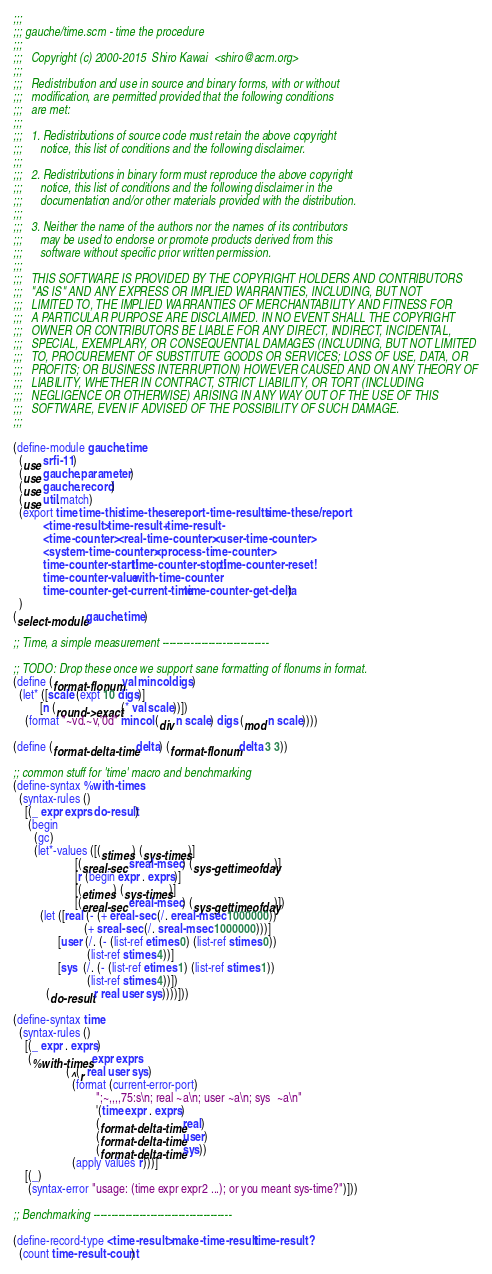Convert code to text. <code><loc_0><loc_0><loc_500><loc_500><_Scheme_>;;;
;;; gauche/time.scm - time the procedure
;;;
;;;   Copyright (c) 2000-2015  Shiro Kawai  <shiro@acm.org>
;;;
;;;   Redistribution and use in source and binary forms, with or without
;;;   modification, are permitted provided that the following conditions
;;;   are met:
;;;
;;;   1. Redistributions of source code must retain the above copyright
;;;      notice, this list of conditions and the following disclaimer.
;;;
;;;   2. Redistributions in binary form must reproduce the above copyright
;;;      notice, this list of conditions and the following disclaimer in the
;;;      documentation and/or other materials provided with the distribution.
;;;
;;;   3. Neither the name of the authors nor the names of its contributors
;;;      may be used to endorse or promote products derived from this
;;;      software without specific prior written permission.
;;;
;;;   THIS SOFTWARE IS PROVIDED BY THE COPYRIGHT HOLDERS AND CONTRIBUTORS
;;;   "AS IS" AND ANY EXPRESS OR IMPLIED WARRANTIES, INCLUDING, BUT NOT
;;;   LIMITED TO, THE IMPLIED WARRANTIES OF MERCHANTABILITY AND FITNESS FOR
;;;   A PARTICULAR PURPOSE ARE DISCLAIMED. IN NO EVENT SHALL THE COPYRIGHT
;;;   OWNER OR CONTRIBUTORS BE LIABLE FOR ANY DIRECT, INDIRECT, INCIDENTAL,
;;;   SPECIAL, EXEMPLARY, OR CONSEQUENTIAL DAMAGES (INCLUDING, BUT NOT LIMITED
;;;   TO, PROCUREMENT OF SUBSTITUTE GOODS OR SERVICES; LOSS OF USE, DATA, OR
;;;   PROFITS; OR BUSINESS INTERRUPTION) HOWEVER CAUSED AND ON ANY THEORY OF
;;;   LIABILITY, WHETHER IN CONTRACT, STRICT LIABILITY, OR TORT (INCLUDING
;;;   NEGLIGENCE OR OTHERWISE) ARISING IN ANY WAY OUT OF THE USE OF THIS
;;;   SOFTWARE, EVEN IF ADVISED OF THE POSSIBILITY OF SUCH DAMAGE.
;;;

(define-module gauche.time
  (use srfi-11)
  (use gauche.parameter)
  (use gauche.record)
  (use util.match)
  (export time time-this time-these report-time-results time-these/report
          <time-result> time-result+ time-result-
          <time-counter> <real-time-counter> <user-time-counter>
          <system-time-counter> <process-time-counter>
          time-counter-start! time-counter-stop! time-counter-reset!
          time-counter-value with-time-counter
          time-counter-get-current-time time-counter-get-delta)
  )
(select-module gauche.time)

;; Time, a simple measurement ------------------------------

;; TODO: Drop these once we support sane formatting of flonums in format.
(define (format-flonum val mincol digs)
  (let* ([scale (expt 10 digs)]
         [n (round->exact (* val scale))])
    (format "~vd.~v,'0d" mincol (div n scale) digs (mod n scale))))

(define (format-delta-time delta) (format-flonum delta 3 3))

;; common stuff for 'time' macro and benchmarking
(define-syntax %with-times
  (syntax-rules ()
    [(_ expr exprs do-result)
     (begin
       (gc)
       (let*-values ([(stimes) (sys-times)]
                     [(sreal-sec sreal-msec) (sys-gettimeofday)]
                     [r (begin expr . exprs)]
                     [(etimes) (sys-times)]
                     [(ereal-sec ereal-msec) (sys-gettimeofday)])
         (let ([real (- (+ ereal-sec (/. ereal-msec 1000000))
                        (+ sreal-sec (/. sreal-msec 1000000)))]
               [user (/. (- (list-ref etimes 0) (list-ref stimes 0))
                         (list-ref stimes 4))]
               [sys  (/. (- (list-ref etimes 1) (list-ref stimes 1))
                         (list-ref stimes 4))])
           (do-result r real user sys))))]))

(define-syntax time
  (syntax-rules ()
    [(_ expr . exprs)
     (%with-times expr exprs
                  (^(r real user sys)
                    (format (current-error-port)
                            ";~,,,,75:s\n; real ~a\n; user ~a\n; sys  ~a\n"
                            '(time expr . exprs)
                            (format-delta-time real)
                            (format-delta-time user)
                            (format-delta-time sys))
                    (apply values r)))]
    [(_)
     (syntax-error "usage: (time expr expr2 ...); or you meant sys-time?")]))

;; Benchmarking ---------------------------------------

(define-record-type <time-result> make-time-result time-result?
  (count time-result-count)</code> 